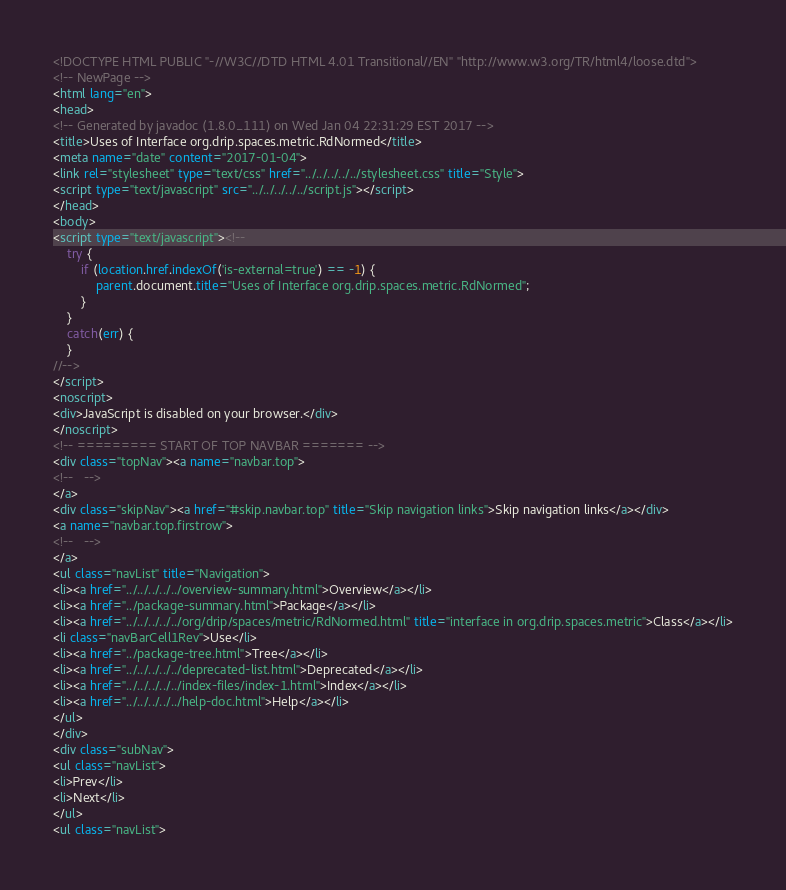<code> <loc_0><loc_0><loc_500><loc_500><_HTML_><!DOCTYPE HTML PUBLIC "-//W3C//DTD HTML 4.01 Transitional//EN" "http://www.w3.org/TR/html4/loose.dtd">
<!-- NewPage -->
<html lang="en">
<head>
<!-- Generated by javadoc (1.8.0_111) on Wed Jan 04 22:31:29 EST 2017 -->
<title>Uses of Interface org.drip.spaces.metric.RdNormed</title>
<meta name="date" content="2017-01-04">
<link rel="stylesheet" type="text/css" href="../../../../../stylesheet.css" title="Style">
<script type="text/javascript" src="../../../../../script.js"></script>
</head>
<body>
<script type="text/javascript"><!--
    try {
        if (location.href.indexOf('is-external=true') == -1) {
            parent.document.title="Uses of Interface org.drip.spaces.metric.RdNormed";
        }
    }
    catch(err) {
    }
//-->
</script>
<noscript>
<div>JavaScript is disabled on your browser.</div>
</noscript>
<!-- ========= START OF TOP NAVBAR ======= -->
<div class="topNav"><a name="navbar.top">
<!--   -->
</a>
<div class="skipNav"><a href="#skip.navbar.top" title="Skip navigation links">Skip navigation links</a></div>
<a name="navbar.top.firstrow">
<!--   -->
</a>
<ul class="navList" title="Navigation">
<li><a href="../../../../../overview-summary.html">Overview</a></li>
<li><a href="../package-summary.html">Package</a></li>
<li><a href="../../../../../org/drip/spaces/metric/RdNormed.html" title="interface in org.drip.spaces.metric">Class</a></li>
<li class="navBarCell1Rev">Use</li>
<li><a href="../package-tree.html">Tree</a></li>
<li><a href="../../../../../deprecated-list.html">Deprecated</a></li>
<li><a href="../../../../../index-files/index-1.html">Index</a></li>
<li><a href="../../../../../help-doc.html">Help</a></li>
</ul>
</div>
<div class="subNav">
<ul class="navList">
<li>Prev</li>
<li>Next</li>
</ul>
<ul class="navList"></code> 